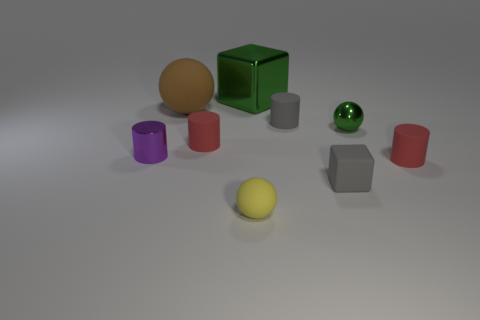Does the small shiny sphere have the same color as the big cube?
Your response must be concise. Yes. What material is the block in front of the small object that is behind the tiny green metal sphere?
Offer a very short reply. Rubber. There is a purple cylinder; does it have the same size as the green shiny object that is left of the tiny green thing?
Your answer should be very brief. No. There is a block that is behind the small purple cylinder; what is its material?
Provide a succinct answer. Metal. How many objects are both behind the tiny gray matte cylinder and to the left of the yellow object?
Provide a short and direct response. 1. There is a green object that is the same size as the brown ball; what is its material?
Provide a succinct answer. Metal. There is a red cylinder that is on the left side of the green sphere; is its size the same as the block to the left of the gray cylinder?
Your response must be concise. No. Are there any tiny green metal objects to the left of the tiny metal cylinder?
Your answer should be compact. No. The matte cube that is to the left of the small red thing that is right of the small yellow thing is what color?
Your response must be concise. Gray. Are there fewer green matte cylinders than large metallic cubes?
Give a very brief answer. Yes. 